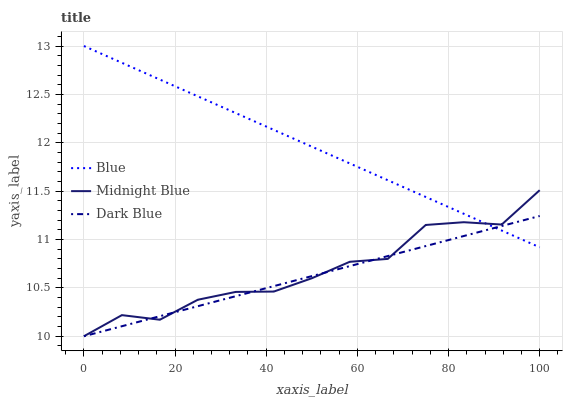Does Dark Blue have the minimum area under the curve?
Answer yes or no. Yes. Does Blue have the maximum area under the curve?
Answer yes or no. Yes. Does Midnight Blue have the minimum area under the curve?
Answer yes or no. No. Does Midnight Blue have the maximum area under the curve?
Answer yes or no. No. Is Dark Blue the smoothest?
Answer yes or no. Yes. Is Midnight Blue the roughest?
Answer yes or no. Yes. Is Midnight Blue the smoothest?
Answer yes or no. No. Is Dark Blue the roughest?
Answer yes or no. No. Does Blue have the highest value?
Answer yes or no. Yes. Does Midnight Blue have the highest value?
Answer yes or no. No. Does Midnight Blue intersect Blue?
Answer yes or no. Yes. Is Midnight Blue less than Blue?
Answer yes or no. No. Is Midnight Blue greater than Blue?
Answer yes or no. No. 